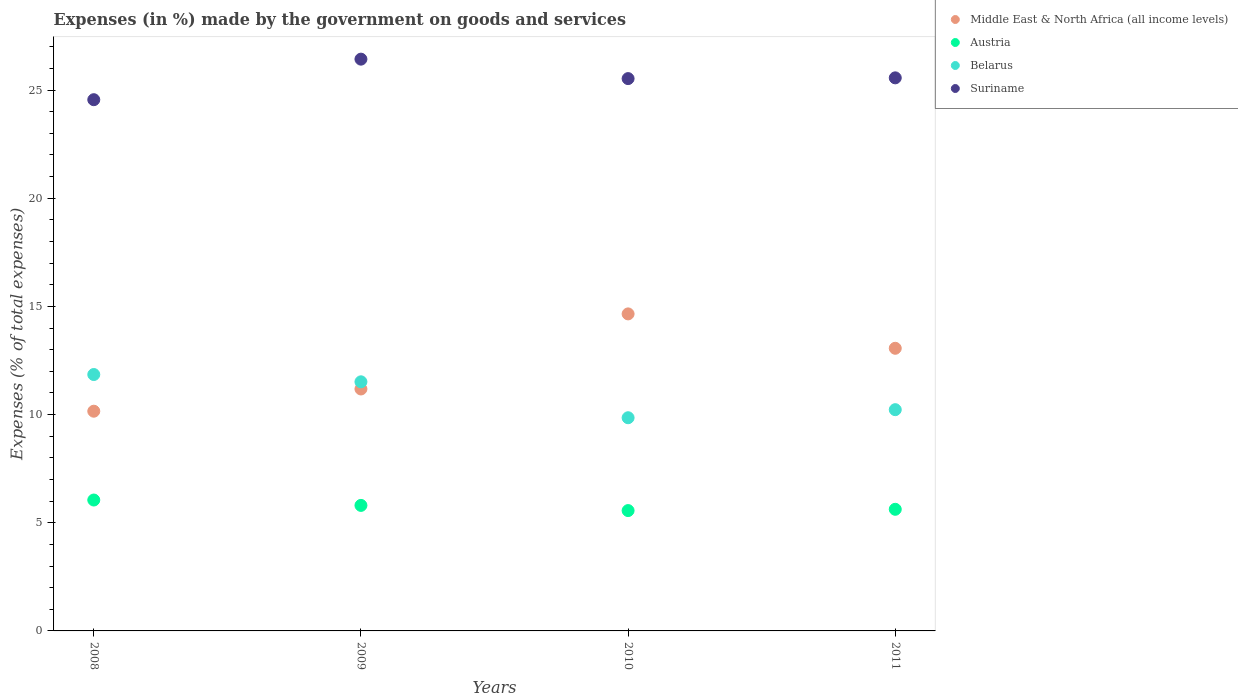How many different coloured dotlines are there?
Provide a succinct answer. 4. Is the number of dotlines equal to the number of legend labels?
Your answer should be very brief. Yes. What is the percentage of expenses made by the government on goods and services in Belarus in 2008?
Make the answer very short. 11.85. Across all years, what is the maximum percentage of expenses made by the government on goods and services in Austria?
Make the answer very short. 6.05. Across all years, what is the minimum percentage of expenses made by the government on goods and services in Belarus?
Your answer should be compact. 9.85. In which year was the percentage of expenses made by the government on goods and services in Belarus minimum?
Provide a short and direct response. 2010. What is the total percentage of expenses made by the government on goods and services in Suriname in the graph?
Your response must be concise. 102.08. What is the difference between the percentage of expenses made by the government on goods and services in Belarus in 2009 and that in 2010?
Give a very brief answer. 1.66. What is the difference between the percentage of expenses made by the government on goods and services in Austria in 2011 and the percentage of expenses made by the government on goods and services in Middle East & North Africa (all income levels) in 2010?
Ensure brevity in your answer.  -9.03. What is the average percentage of expenses made by the government on goods and services in Middle East & North Africa (all income levels) per year?
Your answer should be compact. 12.26. In the year 2011, what is the difference between the percentage of expenses made by the government on goods and services in Belarus and percentage of expenses made by the government on goods and services in Austria?
Ensure brevity in your answer.  4.61. What is the ratio of the percentage of expenses made by the government on goods and services in Middle East & North Africa (all income levels) in 2009 to that in 2011?
Offer a very short reply. 0.86. What is the difference between the highest and the second highest percentage of expenses made by the government on goods and services in Middle East & North Africa (all income levels)?
Provide a succinct answer. 1.59. What is the difference between the highest and the lowest percentage of expenses made by the government on goods and services in Middle East & North Africa (all income levels)?
Your answer should be compact. 4.5. In how many years, is the percentage of expenses made by the government on goods and services in Suriname greater than the average percentage of expenses made by the government on goods and services in Suriname taken over all years?
Your response must be concise. 3. Is it the case that in every year, the sum of the percentage of expenses made by the government on goods and services in Austria and percentage of expenses made by the government on goods and services in Suriname  is greater than the sum of percentage of expenses made by the government on goods and services in Middle East & North Africa (all income levels) and percentage of expenses made by the government on goods and services in Belarus?
Your response must be concise. Yes. Is it the case that in every year, the sum of the percentage of expenses made by the government on goods and services in Belarus and percentage of expenses made by the government on goods and services in Suriname  is greater than the percentage of expenses made by the government on goods and services in Austria?
Your answer should be very brief. Yes. How many dotlines are there?
Ensure brevity in your answer.  4. How many years are there in the graph?
Make the answer very short. 4. Are the values on the major ticks of Y-axis written in scientific E-notation?
Keep it short and to the point. No. How are the legend labels stacked?
Give a very brief answer. Vertical. What is the title of the graph?
Offer a terse response. Expenses (in %) made by the government on goods and services. What is the label or title of the Y-axis?
Your answer should be compact. Expenses (% of total expenses). What is the Expenses (% of total expenses) in Middle East & North Africa (all income levels) in 2008?
Offer a very short reply. 10.16. What is the Expenses (% of total expenses) in Austria in 2008?
Give a very brief answer. 6.05. What is the Expenses (% of total expenses) of Belarus in 2008?
Ensure brevity in your answer.  11.85. What is the Expenses (% of total expenses) in Suriname in 2008?
Offer a terse response. 24.56. What is the Expenses (% of total expenses) in Middle East & North Africa (all income levels) in 2009?
Your answer should be compact. 11.18. What is the Expenses (% of total expenses) of Austria in 2009?
Ensure brevity in your answer.  5.8. What is the Expenses (% of total expenses) of Belarus in 2009?
Your answer should be compact. 11.51. What is the Expenses (% of total expenses) of Suriname in 2009?
Give a very brief answer. 26.43. What is the Expenses (% of total expenses) in Middle East & North Africa (all income levels) in 2010?
Your answer should be very brief. 14.65. What is the Expenses (% of total expenses) of Austria in 2010?
Provide a succinct answer. 5.56. What is the Expenses (% of total expenses) of Belarus in 2010?
Your response must be concise. 9.85. What is the Expenses (% of total expenses) in Suriname in 2010?
Keep it short and to the point. 25.53. What is the Expenses (% of total expenses) of Middle East & North Africa (all income levels) in 2011?
Offer a very short reply. 13.06. What is the Expenses (% of total expenses) in Austria in 2011?
Offer a terse response. 5.62. What is the Expenses (% of total expenses) of Belarus in 2011?
Your answer should be compact. 10.23. What is the Expenses (% of total expenses) of Suriname in 2011?
Offer a terse response. 25.57. Across all years, what is the maximum Expenses (% of total expenses) of Middle East & North Africa (all income levels)?
Give a very brief answer. 14.65. Across all years, what is the maximum Expenses (% of total expenses) in Austria?
Keep it short and to the point. 6.05. Across all years, what is the maximum Expenses (% of total expenses) in Belarus?
Provide a succinct answer. 11.85. Across all years, what is the maximum Expenses (% of total expenses) in Suriname?
Your answer should be very brief. 26.43. Across all years, what is the minimum Expenses (% of total expenses) of Middle East & North Africa (all income levels)?
Ensure brevity in your answer.  10.16. Across all years, what is the minimum Expenses (% of total expenses) of Austria?
Offer a terse response. 5.56. Across all years, what is the minimum Expenses (% of total expenses) in Belarus?
Keep it short and to the point. 9.85. Across all years, what is the minimum Expenses (% of total expenses) of Suriname?
Ensure brevity in your answer.  24.56. What is the total Expenses (% of total expenses) of Middle East & North Africa (all income levels) in the graph?
Make the answer very short. 49.06. What is the total Expenses (% of total expenses) in Austria in the graph?
Keep it short and to the point. 23.04. What is the total Expenses (% of total expenses) in Belarus in the graph?
Provide a short and direct response. 43.45. What is the total Expenses (% of total expenses) in Suriname in the graph?
Provide a short and direct response. 102.08. What is the difference between the Expenses (% of total expenses) in Middle East & North Africa (all income levels) in 2008 and that in 2009?
Keep it short and to the point. -1.03. What is the difference between the Expenses (% of total expenses) in Austria in 2008 and that in 2009?
Your answer should be compact. 0.25. What is the difference between the Expenses (% of total expenses) in Belarus in 2008 and that in 2009?
Your answer should be very brief. 0.34. What is the difference between the Expenses (% of total expenses) of Suriname in 2008 and that in 2009?
Give a very brief answer. -1.87. What is the difference between the Expenses (% of total expenses) in Middle East & North Africa (all income levels) in 2008 and that in 2010?
Provide a succinct answer. -4.5. What is the difference between the Expenses (% of total expenses) in Austria in 2008 and that in 2010?
Your answer should be very brief. 0.49. What is the difference between the Expenses (% of total expenses) in Belarus in 2008 and that in 2010?
Offer a very short reply. 2. What is the difference between the Expenses (% of total expenses) in Suriname in 2008 and that in 2010?
Offer a very short reply. -0.97. What is the difference between the Expenses (% of total expenses) of Middle East & North Africa (all income levels) in 2008 and that in 2011?
Your answer should be very brief. -2.91. What is the difference between the Expenses (% of total expenses) of Austria in 2008 and that in 2011?
Provide a short and direct response. 0.43. What is the difference between the Expenses (% of total expenses) in Belarus in 2008 and that in 2011?
Your response must be concise. 1.62. What is the difference between the Expenses (% of total expenses) of Suriname in 2008 and that in 2011?
Ensure brevity in your answer.  -1.01. What is the difference between the Expenses (% of total expenses) in Middle East & North Africa (all income levels) in 2009 and that in 2010?
Make the answer very short. -3.47. What is the difference between the Expenses (% of total expenses) of Austria in 2009 and that in 2010?
Your response must be concise. 0.24. What is the difference between the Expenses (% of total expenses) of Belarus in 2009 and that in 2010?
Offer a very short reply. 1.66. What is the difference between the Expenses (% of total expenses) in Suriname in 2009 and that in 2010?
Offer a terse response. 0.9. What is the difference between the Expenses (% of total expenses) of Middle East & North Africa (all income levels) in 2009 and that in 2011?
Provide a short and direct response. -1.88. What is the difference between the Expenses (% of total expenses) in Austria in 2009 and that in 2011?
Make the answer very short. 0.18. What is the difference between the Expenses (% of total expenses) in Belarus in 2009 and that in 2011?
Provide a succinct answer. 1.29. What is the difference between the Expenses (% of total expenses) of Suriname in 2009 and that in 2011?
Your answer should be compact. 0.86. What is the difference between the Expenses (% of total expenses) of Middle East & North Africa (all income levels) in 2010 and that in 2011?
Keep it short and to the point. 1.59. What is the difference between the Expenses (% of total expenses) of Austria in 2010 and that in 2011?
Give a very brief answer. -0.06. What is the difference between the Expenses (% of total expenses) in Belarus in 2010 and that in 2011?
Give a very brief answer. -0.37. What is the difference between the Expenses (% of total expenses) of Suriname in 2010 and that in 2011?
Offer a very short reply. -0.03. What is the difference between the Expenses (% of total expenses) of Middle East & North Africa (all income levels) in 2008 and the Expenses (% of total expenses) of Austria in 2009?
Keep it short and to the point. 4.35. What is the difference between the Expenses (% of total expenses) in Middle East & North Africa (all income levels) in 2008 and the Expenses (% of total expenses) in Belarus in 2009?
Your answer should be compact. -1.36. What is the difference between the Expenses (% of total expenses) in Middle East & North Africa (all income levels) in 2008 and the Expenses (% of total expenses) in Suriname in 2009?
Ensure brevity in your answer.  -16.27. What is the difference between the Expenses (% of total expenses) of Austria in 2008 and the Expenses (% of total expenses) of Belarus in 2009?
Your response must be concise. -5.46. What is the difference between the Expenses (% of total expenses) in Austria in 2008 and the Expenses (% of total expenses) in Suriname in 2009?
Keep it short and to the point. -20.38. What is the difference between the Expenses (% of total expenses) of Belarus in 2008 and the Expenses (% of total expenses) of Suriname in 2009?
Ensure brevity in your answer.  -14.58. What is the difference between the Expenses (% of total expenses) in Middle East & North Africa (all income levels) in 2008 and the Expenses (% of total expenses) in Austria in 2010?
Your answer should be compact. 4.59. What is the difference between the Expenses (% of total expenses) in Middle East & North Africa (all income levels) in 2008 and the Expenses (% of total expenses) in Belarus in 2010?
Provide a succinct answer. 0.3. What is the difference between the Expenses (% of total expenses) in Middle East & North Africa (all income levels) in 2008 and the Expenses (% of total expenses) in Suriname in 2010?
Your answer should be very brief. -15.37. What is the difference between the Expenses (% of total expenses) of Austria in 2008 and the Expenses (% of total expenses) of Belarus in 2010?
Offer a very short reply. -3.8. What is the difference between the Expenses (% of total expenses) of Austria in 2008 and the Expenses (% of total expenses) of Suriname in 2010?
Offer a very short reply. -19.48. What is the difference between the Expenses (% of total expenses) of Belarus in 2008 and the Expenses (% of total expenses) of Suriname in 2010?
Your response must be concise. -13.68. What is the difference between the Expenses (% of total expenses) in Middle East & North Africa (all income levels) in 2008 and the Expenses (% of total expenses) in Austria in 2011?
Keep it short and to the point. 4.53. What is the difference between the Expenses (% of total expenses) of Middle East & North Africa (all income levels) in 2008 and the Expenses (% of total expenses) of Belarus in 2011?
Provide a short and direct response. -0.07. What is the difference between the Expenses (% of total expenses) of Middle East & North Africa (all income levels) in 2008 and the Expenses (% of total expenses) of Suriname in 2011?
Keep it short and to the point. -15.41. What is the difference between the Expenses (% of total expenses) of Austria in 2008 and the Expenses (% of total expenses) of Belarus in 2011?
Ensure brevity in your answer.  -4.18. What is the difference between the Expenses (% of total expenses) in Austria in 2008 and the Expenses (% of total expenses) in Suriname in 2011?
Your response must be concise. -19.51. What is the difference between the Expenses (% of total expenses) in Belarus in 2008 and the Expenses (% of total expenses) in Suriname in 2011?
Offer a terse response. -13.71. What is the difference between the Expenses (% of total expenses) of Middle East & North Africa (all income levels) in 2009 and the Expenses (% of total expenses) of Austria in 2010?
Provide a succinct answer. 5.62. What is the difference between the Expenses (% of total expenses) of Middle East & North Africa (all income levels) in 2009 and the Expenses (% of total expenses) of Belarus in 2010?
Offer a terse response. 1.33. What is the difference between the Expenses (% of total expenses) of Middle East & North Africa (all income levels) in 2009 and the Expenses (% of total expenses) of Suriname in 2010?
Your response must be concise. -14.35. What is the difference between the Expenses (% of total expenses) of Austria in 2009 and the Expenses (% of total expenses) of Belarus in 2010?
Your response must be concise. -4.05. What is the difference between the Expenses (% of total expenses) of Austria in 2009 and the Expenses (% of total expenses) of Suriname in 2010?
Provide a succinct answer. -19.73. What is the difference between the Expenses (% of total expenses) in Belarus in 2009 and the Expenses (% of total expenses) in Suriname in 2010?
Give a very brief answer. -14.02. What is the difference between the Expenses (% of total expenses) of Middle East & North Africa (all income levels) in 2009 and the Expenses (% of total expenses) of Austria in 2011?
Ensure brevity in your answer.  5.56. What is the difference between the Expenses (% of total expenses) of Middle East & North Africa (all income levels) in 2009 and the Expenses (% of total expenses) of Belarus in 2011?
Your response must be concise. 0.96. What is the difference between the Expenses (% of total expenses) in Middle East & North Africa (all income levels) in 2009 and the Expenses (% of total expenses) in Suriname in 2011?
Your response must be concise. -14.38. What is the difference between the Expenses (% of total expenses) of Austria in 2009 and the Expenses (% of total expenses) of Belarus in 2011?
Keep it short and to the point. -4.43. What is the difference between the Expenses (% of total expenses) in Austria in 2009 and the Expenses (% of total expenses) in Suriname in 2011?
Ensure brevity in your answer.  -19.76. What is the difference between the Expenses (% of total expenses) of Belarus in 2009 and the Expenses (% of total expenses) of Suriname in 2011?
Provide a succinct answer. -14.05. What is the difference between the Expenses (% of total expenses) in Middle East & North Africa (all income levels) in 2010 and the Expenses (% of total expenses) in Austria in 2011?
Make the answer very short. 9.03. What is the difference between the Expenses (% of total expenses) of Middle East & North Africa (all income levels) in 2010 and the Expenses (% of total expenses) of Belarus in 2011?
Ensure brevity in your answer.  4.43. What is the difference between the Expenses (% of total expenses) of Middle East & North Africa (all income levels) in 2010 and the Expenses (% of total expenses) of Suriname in 2011?
Keep it short and to the point. -10.91. What is the difference between the Expenses (% of total expenses) in Austria in 2010 and the Expenses (% of total expenses) in Belarus in 2011?
Keep it short and to the point. -4.66. What is the difference between the Expenses (% of total expenses) of Austria in 2010 and the Expenses (% of total expenses) of Suriname in 2011?
Give a very brief answer. -20. What is the difference between the Expenses (% of total expenses) in Belarus in 2010 and the Expenses (% of total expenses) in Suriname in 2011?
Your response must be concise. -15.71. What is the average Expenses (% of total expenses) in Middle East & North Africa (all income levels) per year?
Provide a succinct answer. 12.26. What is the average Expenses (% of total expenses) in Austria per year?
Make the answer very short. 5.76. What is the average Expenses (% of total expenses) in Belarus per year?
Your answer should be compact. 10.86. What is the average Expenses (% of total expenses) of Suriname per year?
Keep it short and to the point. 25.52. In the year 2008, what is the difference between the Expenses (% of total expenses) of Middle East & North Africa (all income levels) and Expenses (% of total expenses) of Austria?
Your answer should be very brief. 4.11. In the year 2008, what is the difference between the Expenses (% of total expenses) in Middle East & North Africa (all income levels) and Expenses (% of total expenses) in Belarus?
Your answer should be compact. -1.7. In the year 2008, what is the difference between the Expenses (% of total expenses) of Middle East & North Africa (all income levels) and Expenses (% of total expenses) of Suriname?
Give a very brief answer. -14.4. In the year 2008, what is the difference between the Expenses (% of total expenses) in Austria and Expenses (% of total expenses) in Belarus?
Provide a short and direct response. -5.8. In the year 2008, what is the difference between the Expenses (% of total expenses) of Austria and Expenses (% of total expenses) of Suriname?
Offer a terse response. -18.5. In the year 2008, what is the difference between the Expenses (% of total expenses) in Belarus and Expenses (% of total expenses) in Suriname?
Provide a succinct answer. -12.7. In the year 2009, what is the difference between the Expenses (% of total expenses) of Middle East & North Africa (all income levels) and Expenses (% of total expenses) of Austria?
Offer a very short reply. 5.38. In the year 2009, what is the difference between the Expenses (% of total expenses) in Middle East & North Africa (all income levels) and Expenses (% of total expenses) in Belarus?
Offer a terse response. -0.33. In the year 2009, what is the difference between the Expenses (% of total expenses) of Middle East & North Africa (all income levels) and Expenses (% of total expenses) of Suriname?
Offer a terse response. -15.25. In the year 2009, what is the difference between the Expenses (% of total expenses) of Austria and Expenses (% of total expenses) of Belarus?
Make the answer very short. -5.71. In the year 2009, what is the difference between the Expenses (% of total expenses) of Austria and Expenses (% of total expenses) of Suriname?
Provide a succinct answer. -20.63. In the year 2009, what is the difference between the Expenses (% of total expenses) of Belarus and Expenses (% of total expenses) of Suriname?
Your response must be concise. -14.92. In the year 2010, what is the difference between the Expenses (% of total expenses) of Middle East & North Africa (all income levels) and Expenses (% of total expenses) of Austria?
Ensure brevity in your answer.  9.09. In the year 2010, what is the difference between the Expenses (% of total expenses) of Middle East & North Africa (all income levels) and Expenses (% of total expenses) of Belarus?
Offer a very short reply. 4.8. In the year 2010, what is the difference between the Expenses (% of total expenses) of Middle East & North Africa (all income levels) and Expenses (% of total expenses) of Suriname?
Ensure brevity in your answer.  -10.88. In the year 2010, what is the difference between the Expenses (% of total expenses) in Austria and Expenses (% of total expenses) in Belarus?
Your response must be concise. -4.29. In the year 2010, what is the difference between the Expenses (% of total expenses) in Austria and Expenses (% of total expenses) in Suriname?
Provide a succinct answer. -19.97. In the year 2010, what is the difference between the Expenses (% of total expenses) of Belarus and Expenses (% of total expenses) of Suriname?
Offer a terse response. -15.68. In the year 2011, what is the difference between the Expenses (% of total expenses) of Middle East & North Africa (all income levels) and Expenses (% of total expenses) of Austria?
Your answer should be very brief. 7.44. In the year 2011, what is the difference between the Expenses (% of total expenses) of Middle East & North Africa (all income levels) and Expenses (% of total expenses) of Belarus?
Provide a short and direct response. 2.84. In the year 2011, what is the difference between the Expenses (% of total expenses) of Middle East & North Africa (all income levels) and Expenses (% of total expenses) of Suriname?
Offer a terse response. -12.5. In the year 2011, what is the difference between the Expenses (% of total expenses) in Austria and Expenses (% of total expenses) in Belarus?
Offer a terse response. -4.61. In the year 2011, what is the difference between the Expenses (% of total expenses) of Austria and Expenses (% of total expenses) of Suriname?
Provide a succinct answer. -19.94. In the year 2011, what is the difference between the Expenses (% of total expenses) of Belarus and Expenses (% of total expenses) of Suriname?
Ensure brevity in your answer.  -15.34. What is the ratio of the Expenses (% of total expenses) in Middle East & North Africa (all income levels) in 2008 to that in 2009?
Your answer should be compact. 0.91. What is the ratio of the Expenses (% of total expenses) in Austria in 2008 to that in 2009?
Offer a terse response. 1.04. What is the ratio of the Expenses (% of total expenses) in Belarus in 2008 to that in 2009?
Give a very brief answer. 1.03. What is the ratio of the Expenses (% of total expenses) in Suriname in 2008 to that in 2009?
Your response must be concise. 0.93. What is the ratio of the Expenses (% of total expenses) of Middle East & North Africa (all income levels) in 2008 to that in 2010?
Make the answer very short. 0.69. What is the ratio of the Expenses (% of total expenses) of Austria in 2008 to that in 2010?
Provide a short and direct response. 1.09. What is the ratio of the Expenses (% of total expenses) in Belarus in 2008 to that in 2010?
Your answer should be very brief. 1.2. What is the ratio of the Expenses (% of total expenses) of Suriname in 2008 to that in 2010?
Give a very brief answer. 0.96. What is the ratio of the Expenses (% of total expenses) in Middle East & North Africa (all income levels) in 2008 to that in 2011?
Your response must be concise. 0.78. What is the ratio of the Expenses (% of total expenses) of Austria in 2008 to that in 2011?
Your answer should be very brief. 1.08. What is the ratio of the Expenses (% of total expenses) of Belarus in 2008 to that in 2011?
Make the answer very short. 1.16. What is the ratio of the Expenses (% of total expenses) of Suriname in 2008 to that in 2011?
Your response must be concise. 0.96. What is the ratio of the Expenses (% of total expenses) in Middle East & North Africa (all income levels) in 2009 to that in 2010?
Your answer should be compact. 0.76. What is the ratio of the Expenses (% of total expenses) in Austria in 2009 to that in 2010?
Provide a short and direct response. 1.04. What is the ratio of the Expenses (% of total expenses) of Belarus in 2009 to that in 2010?
Your response must be concise. 1.17. What is the ratio of the Expenses (% of total expenses) of Suriname in 2009 to that in 2010?
Ensure brevity in your answer.  1.04. What is the ratio of the Expenses (% of total expenses) in Middle East & North Africa (all income levels) in 2009 to that in 2011?
Provide a short and direct response. 0.86. What is the ratio of the Expenses (% of total expenses) of Austria in 2009 to that in 2011?
Offer a very short reply. 1.03. What is the ratio of the Expenses (% of total expenses) in Belarus in 2009 to that in 2011?
Ensure brevity in your answer.  1.13. What is the ratio of the Expenses (% of total expenses) of Suriname in 2009 to that in 2011?
Ensure brevity in your answer.  1.03. What is the ratio of the Expenses (% of total expenses) in Middle East & North Africa (all income levels) in 2010 to that in 2011?
Keep it short and to the point. 1.12. What is the ratio of the Expenses (% of total expenses) of Belarus in 2010 to that in 2011?
Give a very brief answer. 0.96. What is the difference between the highest and the second highest Expenses (% of total expenses) of Middle East & North Africa (all income levels)?
Offer a very short reply. 1.59. What is the difference between the highest and the second highest Expenses (% of total expenses) in Austria?
Keep it short and to the point. 0.25. What is the difference between the highest and the second highest Expenses (% of total expenses) of Belarus?
Make the answer very short. 0.34. What is the difference between the highest and the second highest Expenses (% of total expenses) in Suriname?
Keep it short and to the point. 0.86. What is the difference between the highest and the lowest Expenses (% of total expenses) in Middle East & North Africa (all income levels)?
Make the answer very short. 4.5. What is the difference between the highest and the lowest Expenses (% of total expenses) in Austria?
Your response must be concise. 0.49. What is the difference between the highest and the lowest Expenses (% of total expenses) of Belarus?
Your response must be concise. 2. What is the difference between the highest and the lowest Expenses (% of total expenses) in Suriname?
Your response must be concise. 1.87. 